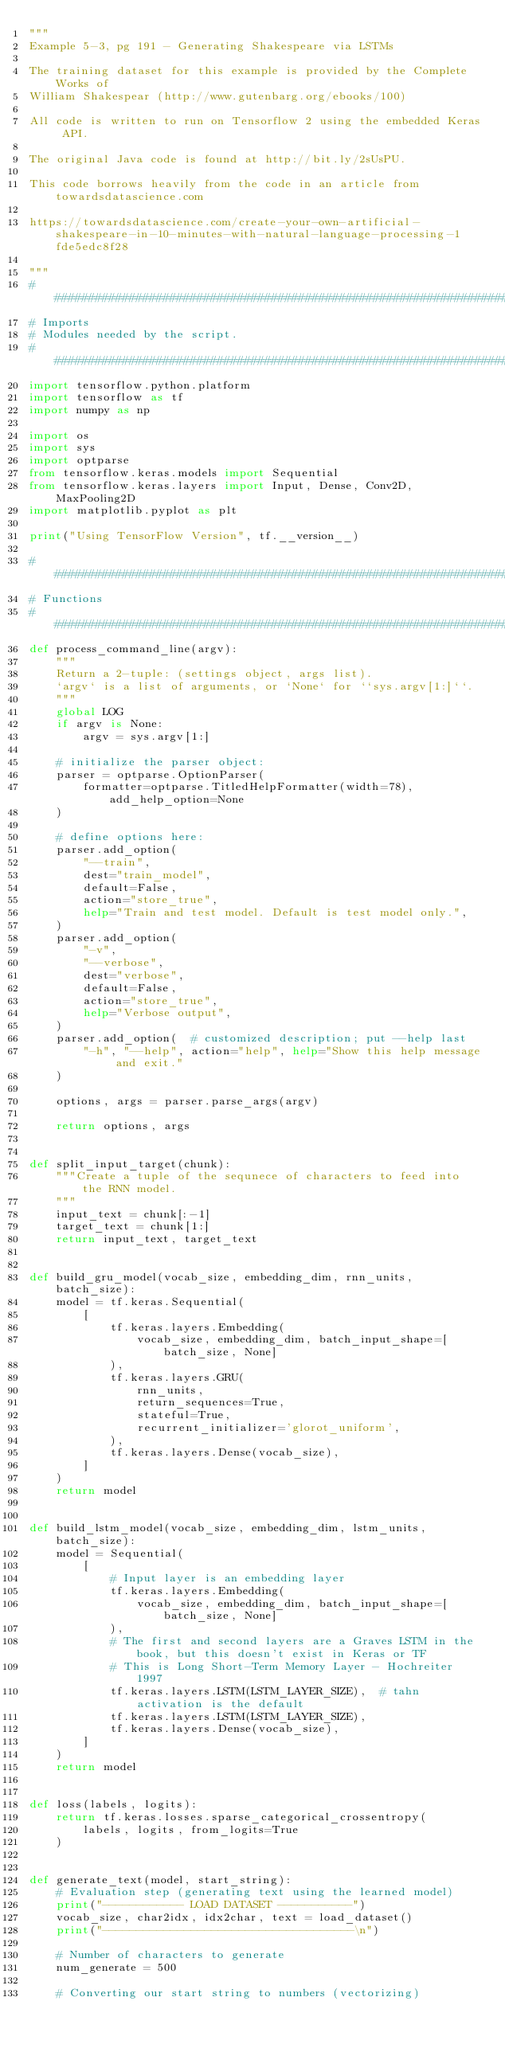Convert code to text. <code><loc_0><loc_0><loc_500><loc_500><_Python_>"""
Example 5-3, pg 191 - Generating Shakespeare via LSTMs

The training dataset for this example is provided by the Complete Works of
William Shakespear (http://www.gutenbarg.org/ebooks/100)

All code is written to run on Tensorflow 2 using the embedded Keras API.

The original Java code is found at http://bit.ly/2sUsPU.

This code borrows heavily from the code in an article from towardsdatascience.com

https://towardsdatascience.com/create-your-own-artificial-shakespeare-in-10-minutes-with-natural-language-processing-1fde5edc8f28

"""
###############################################################################
# Imports
# Modules needed by the script.
###############################################################################
import tensorflow.python.platform
import tensorflow as tf
import numpy as np

import os
import sys
import optparse
from tensorflow.keras.models import Sequential
from tensorflow.keras.layers import Input, Dense, Conv2D, MaxPooling2D
import matplotlib.pyplot as plt

print("Using TensorFlow Version", tf.__version__)

###############################################################################
# Functions
###############################################################################
def process_command_line(argv):
    """
    Return a 2-tuple: (settings object, args list).
    `argv` is a list of arguments, or `None` for ``sys.argv[1:]``.
    """
    global LOG
    if argv is None:
        argv = sys.argv[1:]

    # initialize the parser object:
    parser = optparse.OptionParser(
        formatter=optparse.TitledHelpFormatter(width=78), add_help_option=None
    )

    # define options here:
    parser.add_option(
        "--train",
        dest="train_model",
        default=False,
        action="store_true",
        help="Train and test model. Default is test model only.",
    )
    parser.add_option(
        "-v",
        "--verbose",
        dest="verbose",
        default=False,
        action="store_true",
        help="Verbose output",
    )
    parser.add_option(  # customized description; put --help last
        "-h", "--help", action="help", help="Show this help message and exit."
    )

    options, args = parser.parse_args(argv)

    return options, args


def split_input_target(chunk):
    """Create a tuple of the sequnece of characters to feed into the RNN model.
    """
    input_text = chunk[:-1]
    target_text = chunk[1:]
    return input_text, target_text


def build_gru_model(vocab_size, embedding_dim, rnn_units, batch_size):
    model = tf.keras.Sequential(
        [
            tf.keras.layers.Embedding(
                vocab_size, embedding_dim, batch_input_shape=[batch_size, None]
            ),
            tf.keras.layers.GRU(
                rnn_units,
                return_sequences=True,
                stateful=True,
                recurrent_initializer='glorot_uniform',
            ),
            tf.keras.layers.Dense(vocab_size),
        ]
    )
    return model


def build_lstm_model(vocab_size, embedding_dim, lstm_units, batch_size):
    model = Sequential(
        [
            # Input layer is an embedding layer
            tf.keras.layers.Embedding(
                vocab_size, embedding_dim, batch_input_shape=[batch_size, None]
            ),
            # The first and second layers are a Graves LSTM in the book, but this doesn't exist in Keras or TF
            # This is Long Short-Term Memory Layer - Hochreiter 1997
            tf.keras.layers.LSTM(LSTM_LAYER_SIZE),  # tahn activation is the default
            tf.keras.layers.LSTM(LSTM_LAYER_SIZE),
            tf.keras.layers.Dense(vocab_size),
        ]
    )
    return model


def loss(labels, logits):
    return tf.keras.losses.sparse_categorical_crossentropy(
        labels, logits, from_logits=True
    )


def generate_text(model, start_string):
    # Evaluation step (generating text using the learned model)
    print("------------ LOAD DATASET -----------")
    vocab_size, char2idx, idx2char, text = load_dataset()
    print("-------------------------------------\n")

    # Number of characters to generate
    num_generate = 500

    # Converting our start string to numbers (vectorizing)</code> 